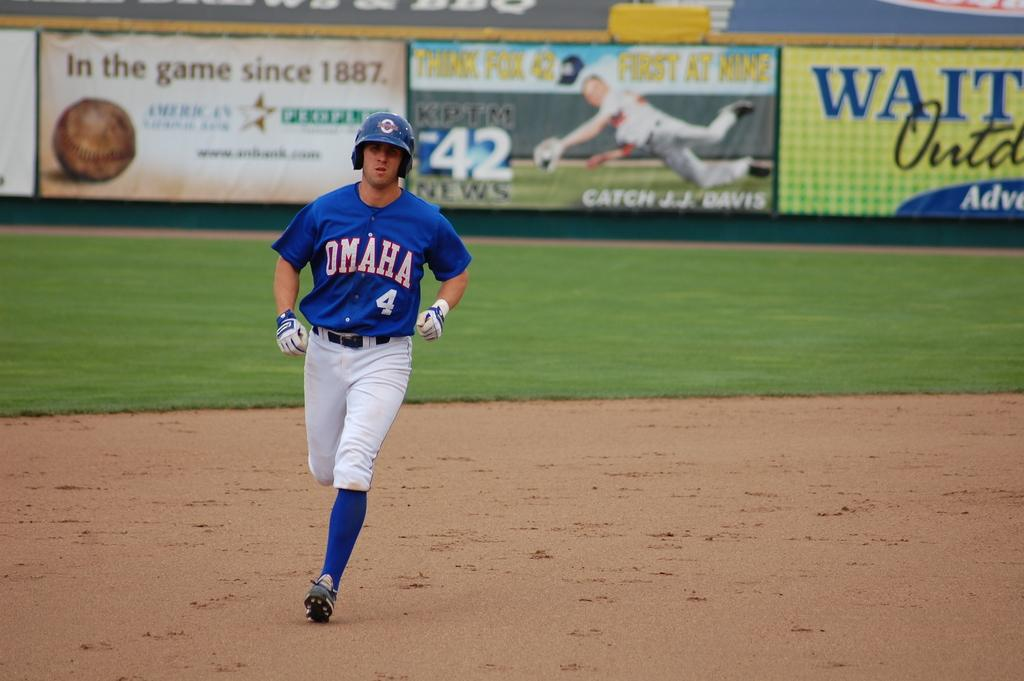What is the sportsman doing in the image? The sportsman is running in the image. What can be seen in the background of the image? There are boards in the background of the image. What type of surface is visible at the bottom of the image? There is ground visible at the bottom of the image. What type of texture can be seen on the bread in the image? There is no bread present in the image. 